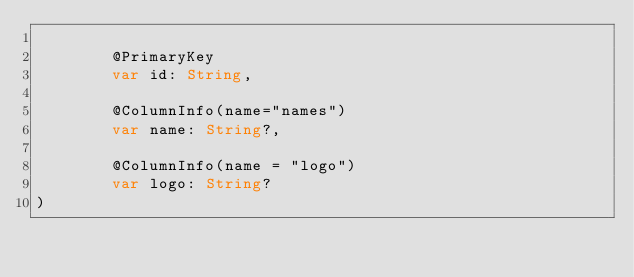Convert code to text. <code><loc_0><loc_0><loc_500><loc_500><_Kotlin_>
        @PrimaryKey
        var id: String,

        @ColumnInfo(name="names")
        var name: String?,

        @ColumnInfo(name = "logo")
        var logo: String?
)</code> 